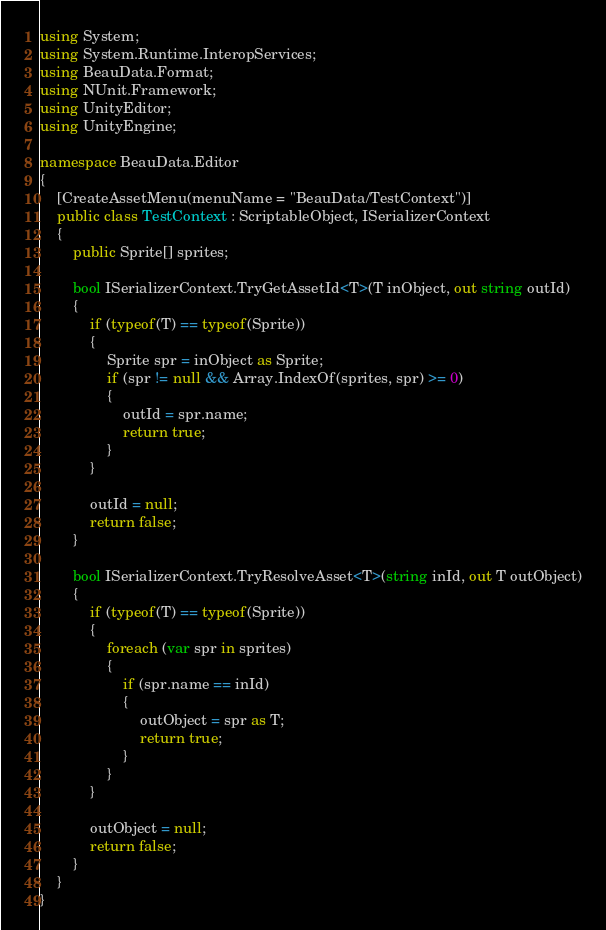Convert code to text. <code><loc_0><loc_0><loc_500><loc_500><_C#_>using System;
using System.Runtime.InteropServices;
using BeauData.Format;
using NUnit.Framework;
using UnityEditor;
using UnityEngine;

namespace BeauData.Editor
{
    [CreateAssetMenu(menuName = "BeauData/TestContext")]
    public class TestContext : ScriptableObject, ISerializerContext
    {
        public Sprite[] sprites;

        bool ISerializerContext.TryGetAssetId<T>(T inObject, out string outId)
        {
            if (typeof(T) == typeof(Sprite))
            {
                Sprite spr = inObject as Sprite;
                if (spr != null && Array.IndexOf(sprites, spr) >= 0)
                {
                    outId = spr.name;
                    return true;
                }
            }

            outId = null;
            return false;
        }

        bool ISerializerContext.TryResolveAsset<T>(string inId, out T outObject)
        {
            if (typeof(T) == typeof(Sprite))
            {
                foreach (var spr in sprites)
                {
                    if (spr.name == inId)
                    {
                        outObject = spr as T;
                        return true;
                    }
                }
            }

            outObject = null;
            return false;
        }
    }
}</code> 